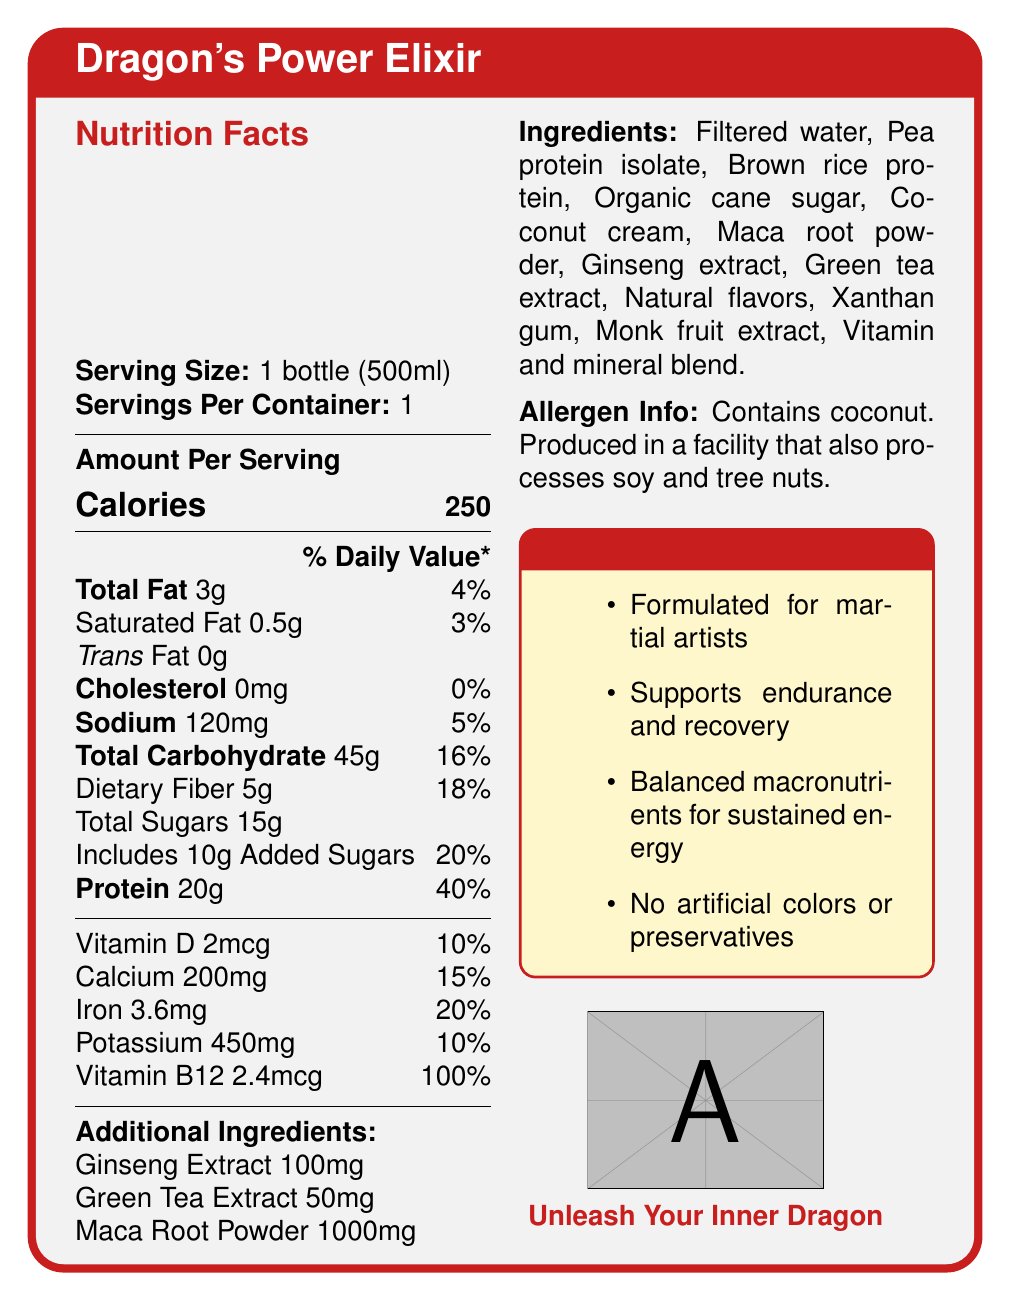what is the serving size of Dragon's Power Elixir? The serving size is listed at the top of the Nutrition Facts section in the rendered document.
Answer: 1 bottle (500ml) how many calories are in one serving of Dragon's Power Elixir? The amount of calories per serving is prominently displayed in the center of the Nutrition Facts section.
Answer: 250 what percentage of the daily value is the protein content per serving? The daily value percentage for protein is listed next to the amount of protein in the Nutrition Facts.
Answer: 40% does Dragon's Power Elixir contain any trans fat? The document specifies that the trans fat content is 0g.
Answer: No what are the main ingredients used in Dragon's Power Elixir? The list of ingredients is provided under the Ingredients section.
Answer: Filtered water, Pea protein isolate, Brown rice protein, Organic cane sugar, Coconut cream, Maca root powder, Ginseng extract, Green tea extract, Natural flavors, Xanthan gum, Monk fruit extract, Vitamin and mineral blend. how much sodium is in Dragon's Power Elixir? The sodium content is listed in the Nutrition Facts section, along with the percentage of the daily value it represents.
Answer: 120mg does Dragon's Power Elixir contain any artificial colors or preservatives? The product claims specifically state that there are no artificial colors or preservatives.
Answer: No what allergen is mentioned in Dragon's Power Elixir? The Allergen Info section specifies that the product contains coconut and is produced in a facility that processes soy and tree nuts.
Answer: Coconut which of the following product claims is NOT made by Dragon's Power Elixir? A. Supports endurance and recovery B. No artificial colors or preservatives C. Vegan and gluten-free The claims listed under the Product Claims section include supporting endurance and recovery, and no artificial colors or preservatives, but there is no mention of the product being vegan and gluten-free.
Answer: C how much Vitamin B12 is in a serving of Dragon's Power Elixir? A. 2mcg B. 200mg C. 2.4mcg D. 2mg The Vitamin B12 content is listed as 2.4mcg in the Nutrition Facts section.
Answer: C how much total carbohydrate does Dragon's Power Elixir have? A. 10g B. 30g C. 45g D. 20g The total carbohydrate content is listed as 45g.
Answer: C is Dragon's Power Elixir formulated for martial artists? One of the product claims mentioned is that it is formulated for martial artists.
Answer: Yes summarize the document. The document provides detailed nutrition facts, ingredients, allergen information, and product claims for Dragon's Power Elixir.
Answer: Dragon's Power Elixir is a meal replacement drink specially formulated for martial artists. It provides 250 calories per 500ml bottle and includes various nutrients like 20g protein, 45g carbohydrates, 5g fiber, and 15g total sugars. The drink also contains added beneficial ingredients like ginseng extract, green tea extract, and maca root powder. Claims include supporting endurance, recovery, and no artificial colors or preservatives. The drink has clear labeling for allergen information and all necessary nutrition facts. how much ginseng extract is in Dragon's Power Elixir? The amount of ginseng extract is specifically listed under Additional Ingredients in the Nutrition Facts section.
Answer: 100mg does Dragon's Power Elixir help in building muscle? The document does not provide sufficient information to conclude whether the drink helps in building muscle.
Answer: Cannot be determined 